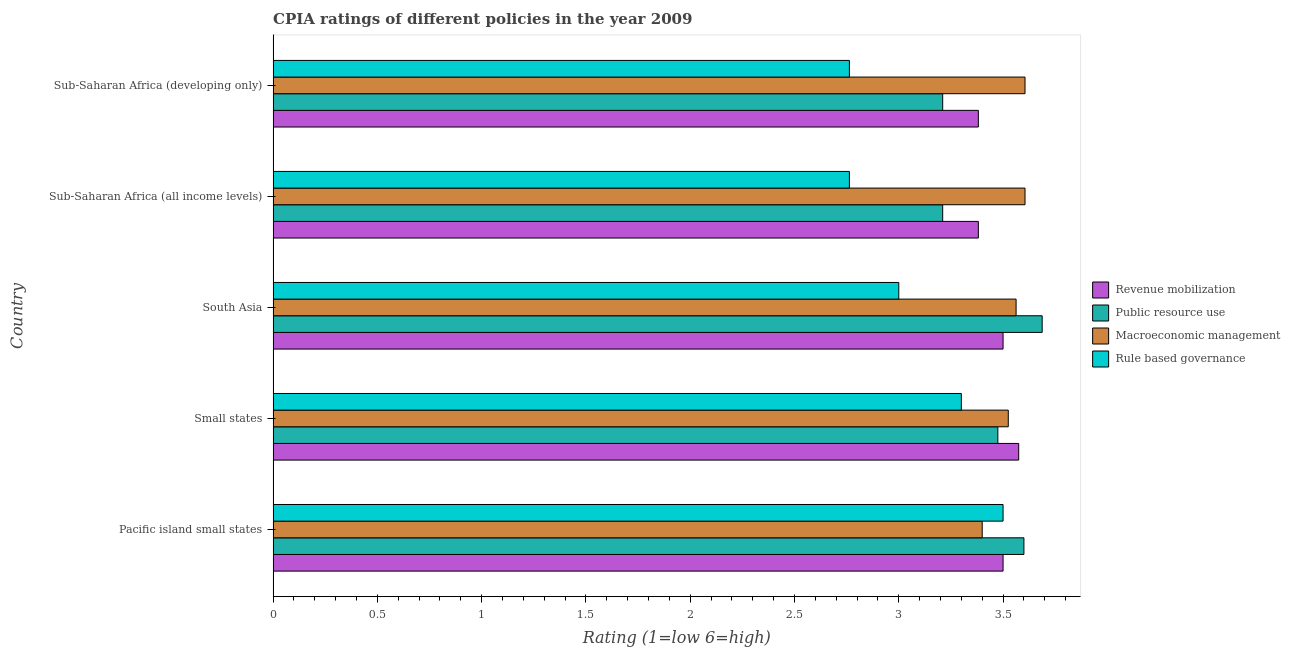How many groups of bars are there?
Offer a very short reply. 5. Are the number of bars per tick equal to the number of legend labels?
Make the answer very short. Yes. What is the label of the 1st group of bars from the top?
Offer a terse response. Sub-Saharan Africa (developing only). What is the cpia rating of public resource use in Sub-Saharan Africa (developing only)?
Offer a terse response. 3.21. Across all countries, what is the maximum cpia rating of public resource use?
Your answer should be compact. 3.69. Across all countries, what is the minimum cpia rating of rule based governance?
Give a very brief answer. 2.76. In which country was the cpia rating of rule based governance maximum?
Your answer should be compact. Pacific island small states. In which country was the cpia rating of revenue mobilization minimum?
Keep it short and to the point. Sub-Saharan Africa (all income levels). What is the total cpia rating of revenue mobilization in the graph?
Give a very brief answer. 17.34. What is the difference between the cpia rating of revenue mobilization in Small states and that in Sub-Saharan Africa (developing only)?
Ensure brevity in your answer.  0.19. What is the difference between the cpia rating of public resource use in South Asia and the cpia rating of rule based governance in Small states?
Your answer should be very brief. 0.39. What is the average cpia rating of public resource use per country?
Your response must be concise. 3.44. In how many countries, is the cpia rating of revenue mobilization greater than 1.9 ?
Provide a short and direct response. 5. What is the ratio of the cpia rating of public resource use in Small states to that in Sub-Saharan Africa (developing only)?
Your answer should be compact. 1.08. Is the cpia rating of macroeconomic management in South Asia less than that in Sub-Saharan Africa (developing only)?
Keep it short and to the point. Yes. What is the difference between the highest and the lowest cpia rating of revenue mobilization?
Your answer should be compact. 0.19. In how many countries, is the cpia rating of public resource use greater than the average cpia rating of public resource use taken over all countries?
Your answer should be very brief. 3. What does the 1st bar from the top in Pacific island small states represents?
Provide a succinct answer. Rule based governance. What does the 1st bar from the bottom in South Asia represents?
Give a very brief answer. Revenue mobilization. Are all the bars in the graph horizontal?
Give a very brief answer. Yes. Are the values on the major ticks of X-axis written in scientific E-notation?
Make the answer very short. No. Does the graph contain any zero values?
Make the answer very short. No. Does the graph contain grids?
Offer a terse response. No. Where does the legend appear in the graph?
Offer a terse response. Center right. How many legend labels are there?
Give a very brief answer. 4. What is the title of the graph?
Offer a terse response. CPIA ratings of different policies in the year 2009. Does "Plant species" appear as one of the legend labels in the graph?
Your answer should be compact. No. What is the label or title of the X-axis?
Offer a terse response. Rating (1=low 6=high). What is the label or title of the Y-axis?
Offer a terse response. Country. What is the Rating (1=low 6=high) of Public resource use in Pacific island small states?
Make the answer very short. 3.6. What is the Rating (1=low 6=high) of Macroeconomic management in Pacific island small states?
Provide a succinct answer. 3.4. What is the Rating (1=low 6=high) of Rule based governance in Pacific island small states?
Your response must be concise. 3.5. What is the Rating (1=low 6=high) in Revenue mobilization in Small states?
Offer a terse response. 3.58. What is the Rating (1=low 6=high) of Public resource use in Small states?
Provide a short and direct response. 3.48. What is the Rating (1=low 6=high) in Macroeconomic management in Small states?
Your answer should be very brief. 3.52. What is the Rating (1=low 6=high) in Revenue mobilization in South Asia?
Keep it short and to the point. 3.5. What is the Rating (1=low 6=high) in Public resource use in South Asia?
Your answer should be very brief. 3.69. What is the Rating (1=low 6=high) in Macroeconomic management in South Asia?
Your answer should be compact. 3.56. What is the Rating (1=low 6=high) of Rule based governance in South Asia?
Make the answer very short. 3. What is the Rating (1=low 6=high) in Revenue mobilization in Sub-Saharan Africa (all income levels)?
Provide a succinct answer. 3.38. What is the Rating (1=low 6=high) of Public resource use in Sub-Saharan Africa (all income levels)?
Make the answer very short. 3.21. What is the Rating (1=low 6=high) in Macroeconomic management in Sub-Saharan Africa (all income levels)?
Your response must be concise. 3.61. What is the Rating (1=low 6=high) in Rule based governance in Sub-Saharan Africa (all income levels)?
Provide a succinct answer. 2.76. What is the Rating (1=low 6=high) in Revenue mobilization in Sub-Saharan Africa (developing only)?
Your answer should be very brief. 3.38. What is the Rating (1=low 6=high) in Public resource use in Sub-Saharan Africa (developing only)?
Ensure brevity in your answer.  3.21. What is the Rating (1=low 6=high) of Macroeconomic management in Sub-Saharan Africa (developing only)?
Offer a terse response. 3.61. What is the Rating (1=low 6=high) of Rule based governance in Sub-Saharan Africa (developing only)?
Provide a succinct answer. 2.76. Across all countries, what is the maximum Rating (1=low 6=high) of Revenue mobilization?
Your response must be concise. 3.58. Across all countries, what is the maximum Rating (1=low 6=high) of Public resource use?
Your answer should be compact. 3.69. Across all countries, what is the maximum Rating (1=low 6=high) in Macroeconomic management?
Ensure brevity in your answer.  3.61. Across all countries, what is the minimum Rating (1=low 6=high) in Revenue mobilization?
Your response must be concise. 3.38. Across all countries, what is the minimum Rating (1=low 6=high) in Public resource use?
Provide a succinct answer. 3.21. Across all countries, what is the minimum Rating (1=low 6=high) of Rule based governance?
Offer a very short reply. 2.76. What is the total Rating (1=low 6=high) of Revenue mobilization in the graph?
Give a very brief answer. 17.34. What is the total Rating (1=low 6=high) of Public resource use in the graph?
Your answer should be compact. 17.18. What is the total Rating (1=low 6=high) of Macroeconomic management in the graph?
Make the answer very short. 17.7. What is the total Rating (1=low 6=high) of Rule based governance in the graph?
Make the answer very short. 15.33. What is the difference between the Rating (1=low 6=high) of Revenue mobilization in Pacific island small states and that in Small states?
Your answer should be very brief. -0.07. What is the difference between the Rating (1=low 6=high) of Public resource use in Pacific island small states and that in Small states?
Your answer should be very brief. 0.12. What is the difference between the Rating (1=low 6=high) of Macroeconomic management in Pacific island small states and that in Small states?
Your answer should be compact. -0.12. What is the difference between the Rating (1=low 6=high) of Rule based governance in Pacific island small states and that in Small states?
Ensure brevity in your answer.  0.2. What is the difference between the Rating (1=low 6=high) in Public resource use in Pacific island small states and that in South Asia?
Offer a very short reply. -0.09. What is the difference between the Rating (1=low 6=high) of Macroeconomic management in Pacific island small states and that in South Asia?
Make the answer very short. -0.16. What is the difference between the Rating (1=low 6=high) in Rule based governance in Pacific island small states and that in South Asia?
Provide a succinct answer. 0.5. What is the difference between the Rating (1=low 6=high) in Revenue mobilization in Pacific island small states and that in Sub-Saharan Africa (all income levels)?
Make the answer very short. 0.12. What is the difference between the Rating (1=low 6=high) in Public resource use in Pacific island small states and that in Sub-Saharan Africa (all income levels)?
Your response must be concise. 0.39. What is the difference between the Rating (1=low 6=high) in Macroeconomic management in Pacific island small states and that in Sub-Saharan Africa (all income levels)?
Offer a very short reply. -0.21. What is the difference between the Rating (1=low 6=high) in Rule based governance in Pacific island small states and that in Sub-Saharan Africa (all income levels)?
Give a very brief answer. 0.74. What is the difference between the Rating (1=low 6=high) of Revenue mobilization in Pacific island small states and that in Sub-Saharan Africa (developing only)?
Your response must be concise. 0.12. What is the difference between the Rating (1=low 6=high) of Public resource use in Pacific island small states and that in Sub-Saharan Africa (developing only)?
Make the answer very short. 0.39. What is the difference between the Rating (1=low 6=high) in Macroeconomic management in Pacific island small states and that in Sub-Saharan Africa (developing only)?
Keep it short and to the point. -0.21. What is the difference between the Rating (1=low 6=high) of Rule based governance in Pacific island small states and that in Sub-Saharan Africa (developing only)?
Make the answer very short. 0.74. What is the difference between the Rating (1=low 6=high) of Revenue mobilization in Small states and that in South Asia?
Offer a very short reply. 0.07. What is the difference between the Rating (1=low 6=high) in Public resource use in Small states and that in South Asia?
Provide a succinct answer. -0.21. What is the difference between the Rating (1=low 6=high) in Macroeconomic management in Small states and that in South Asia?
Ensure brevity in your answer.  -0.04. What is the difference between the Rating (1=low 6=high) of Revenue mobilization in Small states and that in Sub-Saharan Africa (all income levels)?
Your answer should be very brief. 0.19. What is the difference between the Rating (1=low 6=high) of Public resource use in Small states and that in Sub-Saharan Africa (all income levels)?
Your answer should be very brief. 0.26. What is the difference between the Rating (1=low 6=high) of Macroeconomic management in Small states and that in Sub-Saharan Africa (all income levels)?
Ensure brevity in your answer.  -0.08. What is the difference between the Rating (1=low 6=high) of Rule based governance in Small states and that in Sub-Saharan Africa (all income levels)?
Keep it short and to the point. 0.54. What is the difference between the Rating (1=low 6=high) of Revenue mobilization in Small states and that in Sub-Saharan Africa (developing only)?
Offer a terse response. 0.19. What is the difference between the Rating (1=low 6=high) of Public resource use in Small states and that in Sub-Saharan Africa (developing only)?
Your response must be concise. 0.26. What is the difference between the Rating (1=low 6=high) in Macroeconomic management in Small states and that in Sub-Saharan Africa (developing only)?
Provide a short and direct response. -0.08. What is the difference between the Rating (1=low 6=high) of Rule based governance in Small states and that in Sub-Saharan Africa (developing only)?
Offer a very short reply. 0.54. What is the difference between the Rating (1=low 6=high) of Revenue mobilization in South Asia and that in Sub-Saharan Africa (all income levels)?
Your answer should be compact. 0.12. What is the difference between the Rating (1=low 6=high) of Public resource use in South Asia and that in Sub-Saharan Africa (all income levels)?
Your answer should be compact. 0.48. What is the difference between the Rating (1=low 6=high) of Macroeconomic management in South Asia and that in Sub-Saharan Africa (all income levels)?
Ensure brevity in your answer.  -0.04. What is the difference between the Rating (1=low 6=high) of Rule based governance in South Asia and that in Sub-Saharan Africa (all income levels)?
Provide a short and direct response. 0.24. What is the difference between the Rating (1=low 6=high) in Revenue mobilization in South Asia and that in Sub-Saharan Africa (developing only)?
Ensure brevity in your answer.  0.12. What is the difference between the Rating (1=low 6=high) of Public resource use in South Asia and that in Sub-Saharan Africa (developing only)?
Your response must be concise. 0.48. What is the difference between the Rating (1=low 6=high) of Macroeconomic management in South Asia and that in Sub-Saharan Africa (developing only)?
Your response must be concise. -0.04. What is the difference between the Rating (1=low 6=high) of Rule based governance in South Asia and that in Sub-Saharan Africa (developing only)?
Keep it short and to the point. 0.24. What is the difference between the Rating (1=low 6=high) in Revenue mobilization in Pacific island small states and the Rating (1=low 6=high) in Public resource use in Small states?
Provide a short and direct response. 0.03. What is the difference between the Rating (1=low 6=high) in Revenue mobilization in Pacific island small states and the Rating (1=low 6=high) in Macroeconomic management in Small states?
Keep it short and to the point. -0.03. What is the difference between the Rating (1=low 6=high) in Revenue mobilization in Pacific island small states and the Rating (1=low 6=high) in Rule based governance in Small states?
Provide a succinct answer. 0.2. What is the difference between the Rating (1=low 6=high) of Public resource use in Pacific island small states and the Rating (1=low 6=high) of Macroeconomic management in Small states?
Provide a succinct answer. 0.07. What is the difference between the Rating (1=low 6=high) in Macroeconomic management in Pacific island small states and the Rating (1=low 6=high) in Rule based governance in Small states?
Provide a short and direct response. 0.1. What is the difference between the Rating (1=low 6=high) of Revenue mobilization in Pacific island small states and the Rating (1=low 6=high) of Public resource use in South Asia?
Make the answer very short. -0.19. What is the difference between the Rating (1=low 6=high) in Revenue mobilization in Pacific island small states and the Rating (1=low 6=high) in Macroeconomic management in South Asia?
Your response must be concise. -0.06. What is the difference between the Rating (1=low 6=high) of Revenue mobilization in Pacific island small states and the Rating (1=low 6=high) of Rule based governance in South Asia?
Make the answer very short. 0.5. What is the difference between the Rating (1=low 6=high) of Public resource use in Pacific island small states and the Rating (1=low 6=high) of Macroeconomic management in South Asia?
Provide a short and direct response. 0.04. What is the difference between the Rating (1=low 6=high) of Revenue mobilization in Pacific island small states and the Rating (1=low 6=high) of Public resource use in Sub-Saharan Africa (all income levels)?
Your response must be concise. 0.29. What is the difference between the Rating (1=low 6=high) of Revenue mobilization in Pacific island small states and the Rating (1=low 6=high) of Macroeconomic management in Sub-Saharan Africa (all income levels)?
Provide a short and direct response. -0.11. What is the difference between the Rating (1=low 6=high) of Revenue mobilization in Pacific island small states and the Rating (1=low 6=high) of Rule based governance in Sub-Saharan Africa (all income levels)?
Ensure brevity in your answer.  0.74. What is the difference between the Rating (1=low 6=high) of Public resource use in Pacific island small states and the Rating (1=low 6=high) of Macroeconomic management in Sub-Saharan Africa (all income levels)?
Your response must be concise. -0.01. What is the difference between the Rating (1=low 6=high) in Public resource use in Pacific island small states and the Rating (1=low 6=high) in Rule based governance in Sub-Saharan Africa (all income levels)?
Ensure brevity in your answer.  0.84. What is the difference between the Rating (1=low 6=high) of Macroeconomic management in Pacific island small states and the Rating (1=low 6=high) of Rule based governance in Sub-Saharan Africa (all income levels)?
Offer a terse response. 0.64. What is the difference between the Rating (1=low 6=high) in Revenue mobilization in Pacific island small states and the Rating (1=low 6=high) in Public resource use in Sub-Saharan Africa (developing only)?
Keep it short and to the point. 0.29. What is the difference between the Rating (1=low 6=high) of Revenue mobilization in Pacific island small states and the Rating (1=low 6=high) of Macroeconomic management in Sub-Saharan Africa (developing only)?
Your answer should be compact. -0.11. What is the difference between the Rating (1=low 6=high) in Revenue mobilization in Pacific island small states and the Rating (1=low 6=high) in Rule based governance in Sub-Saharan Africa (developing only)?
Provide a short and direct response. 0.74. What is the difference between the Rating (1=low 6=high) in Public resource use in Pacific island small states and the Rating (1=low 6=high) in Macroeconomic management in Sub-Saharan Africa (developing only)?
Provide a short and direct response. -0.01. What is the difference between the Rating (1=low 6=high) of Public resource use in Pacific island small states and the Rating (1=low 6=high) of Rule based governance in Sub-Saharan Africa (developing only)?
Your answer should be compact. 0.84. What is the difference between the Rating (1=low 6=high) of Macroeconomic management in Pacific island small states and the Rating (1=low 6=high) of Rule based governance in Sub-Saharan Africa (developing only)?
Provide a short and direct response. 0.64. What is the difference between the Rating (1=low 6=high) of Revenue mobilization in Small states and the Rating (1=low 6=high) of Public resource use in South Asia?
Keep it short and to the point. -0.11. What is the difference between the Rating (1=low 6=high) of Revenue mobilization in Small states and the Rating (1=low 6=high) of Macroeconomic management in South Asia?
Your answer should be compact. 0.01. What is the difference between the Rating (1=low 6=high) of Revenue mobilization in Small states and the Rating (1=low 6=high) of Rule based governance in South Asia?
Ensure brevity in your answer.  0.57. What is the difference between the Rating (1=low 6=high) in Public resource use in Small states and the Rating (1=low 6=high) in Macroeconomic management in South Asia?
Ensure brevity in your answer.  -0.09. What is the difference between the Rating (1=low 6=high) of Public resource use in Small states and the Rating (1=low 6=high) of Rule based governance in South Asia?
Your response must be concise. 0.47. What is the difference between the Rating (1=low 6=high) of Macroeconomic management in Small states and the Rating (1=low 6=high) of Rule based governance in South Asia?
Your answer should be very brief. 0.53. What is the difference between the Rating (1=low 6=high) of Revenue mobilization in Small states and the Rating (1=low 6=high) of Public resource use in Sub-Saharan Africa (all income levels)?
Give a very brief answer. 0.36. What is the difference between the Rating (1=low 6=high) in Revenue mobilization in Small states and the Rating (1=low 6=high) in Macroeconomic management in Sub-Saharan Africa (all income levels)?
Your answer should be very brief. -0.03. What is the difference between the Rating (1=low 6=high) of Revenue mobilization in Small states and the Rating (1=low 6=high) of Rule based governance in Sub-Saharan Africa (all income levels)?
Give a very brief answer. 0.81. What is the difference between the Rating (1=low 6=high) of Public resource use in Small states and the Rating (1=low 6=high) of Macroeconomic management in Sub-Saharan Africa (all income levels)?
Make the answer very short. -0.13. What is the difference between the Rating (1=low 6=high) in Public resource use in Small states and the Rating (1=low 6=high) in Rule based governance in Sub-Saharan Africa (all income levels)?
Keep it short and to the point. 0.71. What is the difference between the Rating (1=low 6=high) in Macroeconomic management in Small states and the Rating (1=low 6=high) in Rule based governance in Sub-Saharan Africa (all income levels)?
Provide a succinct answer. 0.76. What is the difference between the Rating (1=low 6=high) of Revenue mobilization in Small states and the Rating (1=low 6=high) of Public resource use in Sub-Saharan Africa (developing only)?
Your answer should be very brief. 0.36. What is the difference between the Rating (1=low 6=high) of Revenue mobilization in Small states and the Rating (1=low 6=high) of Macroeconomic management in Sub-Saharan Africa (developing only)?
Offer a terse response. -0.03. What is the difference between the Rating (1=low 6=high) in Revenue mobilization in Small states and the Rating (1=low 6=high) in Rule based governance in Sub-Saharan Africa (developing only)?
Offer a very short reply. 0.81. What is the difference between the Rating (1=low 6=high) in Public resource use in Small states and the Rating (1=low 6=high) in Macroeconomic management in Sub-Saharan Africa (developing only)?
Provide a succinct answer. -0.13. What is the difference between the Rating (1=low 6=high) of Public resource use in Small states and the Rating (1=low 6=high) of Rule based governance in Sub-Saharan Africa (developing only)?
Offer a terse response. 0.71. What is the difference between the Rating (1=low 6=high) of Macroeconomic management in Small states and the Rating (1=low 6=high) of Rule based governance in Sub-Saharan Africa (developing only)?
Offer a very short reply. 0.76. What is the difference between the Rating (1=low 6=high) in Revenue mobilization in South Asia and the Rating (1=low 6=high) in Public resource use in Sub-Saharan Africa (all income levels)?
Provide a short and direct response. 0.29. What is the difference between the Rating (1=low 6=high) in Revenue mobilization in South Asia and the Rating (1=low 6=high) in Macroeconomic management in Sub-Saharan Africa (all income levels)?
Offer a very short reply. -0.11. What is the difference between the Rating (1=low 6=high) in Revenue mobilization in South Asia and the Rating (1=low 6=high) in Rule based governance in Sub-Saharan Africa (all income levels)?
Give a very brief answer. 0.74. What is the difference between the Rating (1=low 6=high) in Public resource use in South Asia and the Rating (1=low 6=high) in Macroeconomic management in Sub-Saharan Africa (all income levels)?
Your answer should be very brief. 0.08. What is the difference between the Rating (1=low 6=high) in Public resource use in South Asia and the Rating (1=low 6=high) in Rule based governance in Sub-Saharan Africa (all income levels)?
Offer a very short reply. 0.92. What is the difference between the Rating (1=low 6=high) in Macroeconomic management in South Asia and the Rating (1=low 6=high) in Rule based governance in Sub-Saharan Africa (all income levels)?
Offer a terse response. 0.8. What is the difference between the Rating (1=low 6=high) in Revenue mobilization in South Asia and the Rating (1=low 6=high) in Public resource use in Sub-Saharan Africa (developing only)?
Ensure brevity in your answer.  0.29. What is the difference between the Rating (1=low 6=high) in Revenue mobilization in South Asia and the Rating (1=low 6=high) in Macroeconomic management in Sub-Saharan Africa (developing only)?
Give a very brief answer. -0.11. What is the difference between the Rating (1=low 6=high) of Revenue mobilization in South Asia and the Rating (1=low 6=high) of Rule based governance in Sub-Saharan Africa (developing only)?
Provide a succinct answer. 0.74. What is the difference between the Rating (1=low 6=high) of Public resource use in South Asia and the Rating (1=low 6=high) of Macroeconomic management in Sub-Saharan Africa (developing only)?
Provide a short and direct response. 0.08. What is the difference between the Rating (1=low 6=high) in Public resource use in South Asia and the Rating (1=low 6=high) in Rule based governance in Sub-Saharan Africa (developing only)?
Provide a succinct answer. 0.92. What is the difference between the Rating (1=low 6=high) of Macroeconomic management in South Asia and the Rating (1=low 6=high) of Rule based governance in Sub-Saharan Africa (developing only)?
Your response must be concise. 0.8. What is the difference between the Rating (1=low 6=high) in Revenue mobilization in Sub-Saharan Africa (all income levels) and the Rating (1=low 6=high) in Public resource use in Sub-Saharan Africa (developing only)?
Provide a succinct answer. 0.17. What is the difference between the Rating (1=low 6=high) of Revenue mobilization in Sub-Saharan Africa (all income levels) and the Rating (1=low 6=high) of Macroeconomic management in Sub-Saharan Africa (developing only)?
Offer a very short reply. -0.22. What is the difference between the Rating (1=low 6=high) in Revenue mobilization in Sub-Saharan Africa (all income levels) and the Rating (1=low 6=high) in Rule based governance in Sub-Saharan Africa (developing only)?
Your answer should be very brief. 0.62. What is the difference between the Rating (1=low 6=high) of Public resource use in Sub-Saharan Africa (all income levels) and the Rating (1=low 6=high) of Macroeconomic management in Sub-Saharan Africa (developing only)?
Give a very brief answer. -0.39. What is the difference between the Rating (1=low 6=high) of Public resource use in Sub-Saharan Africa (all income levels) and the Rating (1=low 6=high) of Rule based governance in Sub-Saharan Africa (developing only)?
Your answer should be compact. 0.45. What is the difference between the Rating (1=low 6=high) of Macroeconomic management in Sub-Saharan Africa (all income levels) and the Rating (1=low 6=high) of Rule based governance in Sub-Saharan Africa (developing only)?
Offer a very short reply. 0.84. What is the average Rating (1=low 6=high) in Revenue mobilization per country?
Provide a succinct answer. 3.47. What is the average Rating (1=low 6=high) of Public resource use per country?
Your answer should be compact. 3.44. What is the average Rating (1=low 6=high) in Macroeconomic management per country?
Your answer should be compact. 3.54. What is the average Rating (1=low 6=high) of Rule based governance per country?
Offer a terse response. 3.07. What is the difference between the Rating (1=low 6=high) of Revenue mobilization and Rating (1=low 6=high) of Macroeconomic management in Pacific island small states?
Make the answer very short. 0.1. What is the difference between the Rating (1=low 6=high) in Macroeconomic management and Rating (1=low 6=high) in Rule based governance in Pacific island small states?
Offer a very short reply. -0.1. What is the difference between the Rating (1=low 6=high) of Revenue mobilization and Rating (1=low 6=high) of Macroeconomic management in Small states?
Offer a very short reply. 0.05. What is the difference between the Rating (1=low 6=high) of Revenue mobilization and Rating (1=low 6=high) of Rule based governance in Small states?
Your response must be concise. 0.28. What is the difference between the Rating (1=low 6=high) in Public resource use and Rating (1=low 6=high) in Macroeconomic management in Small states?
Ensure brevity in your answer.  -0.05. What is the difference between the Rating (1=low 6=high) in Public resource use and Rating (1=low 6=high) in Rule based governance in Small states?
Ensure brevity in your answer.  0.17. What is the difference between the Rating (1=low 6=high) of Macroeconomic management and Rating (1=low 6=high) of Rule based governance in Small states?
Your answer should be very brief. 0.23. What is the difference between the Rating (1=low 6=high) in Revenue mobilization and Rating (1=low 6=high) in Public resource use in South Asia?
Provide a short and direct response. -0.19. What is the difference between the Rating (1=low 6=high) in Revenue mobilization and Rating (1=low 6=high) in Macroeconomic management in South Asia?
Your answer should be very brief. -0.06. What is the difference between the Rating (1=low 6=high) of Public resource use and Rating (1=low 6=high) of Macroeconomic management in South Asia?
Keep it short and to the point. 0.12. What is the difference between the Rating (1=low 6=high) in Public resource use and Rating (1=low 6=high) in Rule based governance in South Asia?
Provide a succinct answer. 0.69. What is the difference between the Rating (1=low 6=high) of Macroeconomic management and Rating (1=low 6=high) of Rule based governance in South Asia?
Give a very brief answer. 0.56. What is the difference between the Rating (1=low 6=high) in Revenue mobilization and Rating (1=low 6=high) in Public resource use in Sub-Saharan Africa (all income levels)?
Keep it short and to the point. 0.17. What is the difference between the Rating (1=low 6=high) of Revenue mobilization and Rating (1=low 6=high) of Macroeconomic management in Sub-Saharan Africa (all income levels)?
Your answer should be compact. -0.22. What is the difference between the Rating (1=low 6=high) of Revenue mobilization and Rating (1=low 6=high) of Rule based governance in Sub-Saharan Africa (all income levels)?
Your answer should be very brief. 0.62. What is the difference between the Rating (1=low 6=high) of Public resource use and Rating (1=low 6=high) of Macroeconomic management in Sub-Saharan Africa (all income levels)?
Provide a short and direct response. -0.39. What is the difference between the Rating (1=low 6=high) of Public resource use and Rating (1=low 6=high) of Rule based governance in Sub-Saharan Africa (all income levels)?
Your answer should be compact. 0.45. What is the difference between the Rating (1=low 6=high) of Macroeconomic management and Rating (1=low 6=high) of Rule based governance in Sub-Saharan Africa (all income levels)?
Offer a terse response. 0.84. What is the difference between the Rating (1=low 6=high) of Revenue mobilization and Rating (1=low 6=high) of Public resource use in Sub-Saharan Africa (developing only)?
Provide a succinct answer. 0.17. What is the difference between the Rating (1=low 6=high) in Revenue mobilization and Rating (1=low 6=high) in Macroeconomic management in Sub-Saharan Africa (developing only)?
Offer a terse response. -0.22. What is the difference between the Rating (1=low 6=high) of Revenue mobilization and Rating (1=low 6=high) of Rule based governance in Sub-Saharan Africa (developing only)?
Provide a succinct answer. 0.62. What is the difference between the Rating (1=low 6=high) of Public resource use and Rating (1=low 6=high) of Macroeconomic management in Sub-Saharan Africa (developing only)?
Provide a succinct answer. -0.39. What is the difference between the Rating (1=low 6=high) of Public resource use and Rating (1=low 6=high) of Rule based governance in Sub-Saharan Africa (developing only)?
Your answer should be very brief. 0.45. What is the difference between the Rating (1=low 6=high) in Macroeconomic management and Rating (1=low 6=high) in Rule based governance in Sub-Saharan Africa (developing only)?
Give a very brief answer. 0.84. What is the ratio of the Rating (1=low 6=high) of Public resource use in Pacific island small states to that in Small states?
Your response must be concise. 1.04. What is the ratio of the Rating (1=low 6=high) of Macroeconomic management in Pacific island small states to that in Small states?
Your answer should be compact. 0.96. What is the ratio of the Rating (1=low 6=high) of Rule based governance in Pacific island small states to that in Small states?
Give a very brief answer. 1.06. What is the ratio of the Rating (1=low 6=high) in Revenue mobilization in Pacific island small states to that in South Asia?
Ensure brevity in your answer.  1. What is the ratio of the Rating (1=low 6=high) in Public resource use in Pacific island small states to that in South Asia?
Provide a short and direct response. 0.98. What is the ratio of the Rating (1=low 6=high) in Macroeconomic management in Pacific island small states to that in South Asia?
Give a very brief answer. 0.95. What is the ratio of the Rating (1=low 6=high) of Rule based governance in Pacific island small states to that in South Asia?
Ensure brevity in your answer.  1.17. What is the ratio of the Rating (1=low 6=high) in Revenue mobilization in Pacific island small states to that in Sub-Saharan Africa (all income levels)?
Give a very brief answer. 1.03. What is the ratio of the Rating (1=low 6=high) of Public resource use in Pacific island small states to that in Sub-Saharan Africa (all income levels)?
Your answer should be compact. 1.12. What is the ratio of the Rating (1=low 6=high) of Macroeconomic management in Pacific island small states to that in Sub-Saharan Africa (all income levels)?
Provide a succinct answer. 0.94. What is the ratio of the Rating (1=low 6=high) of Rule based governance in Pacific island small states to that in Sub-Saharan Africa (all income levels)?
Your response must be concise. 1.27. What is the ratio of the Rating (1=low 6=high) in Revenue mobilization in Pacific island small states to that in Sub-Saharan Africa (developing only)?
Make the answer very short. 1.03. What is the ratio of the Rating (1=low 6=high) in Public resource use in Pacific island small states to that in Sub-Saharan Africa (developing only)?
Your response must be concise. 1.12. What is the ratio of the Rating (1=low 6=high) of Macroeconomic management in Pacific island small states to that in Sub-Saharan Africa (developing only)?
Keep it short and to the point. 0.94. What is the ratio of the Rating (1=low 6=high) of Rule based governance in Pacific island small states to that in Sub-Saharan Africa (developing only)?
Provide a succinct answer. 1.27. What is the ratio of the Rating (1=low 6=high) of Revenue mobilization in Small states to that in South Asia?
Your response must be concise. 1.02. What is the ratio of the Rating (1=low 6=high) of Public resource use in Small states to that in South Asia?
Keep it short and to the point. 0.94. What is the ratio of the Rating (1=low 6=high) of Revenue mobilization in Small states to that in Sub-Saharan Africa (all income levels)?
Offer a terse response. 1.06. What is the ratio of the Rating (1=low 6=high) in Public resource use in Small states to that in Sub-Saharan Africa (all income levels)?
Make the answer very short. 1.08. What is the ratio of the Rating (1=low 6=high) of Macroeconomic management in Small states to that in Sub-Saharan Africa (all income levels)?
Keep it short and to the point. 0.98. What is the ratio of the Rating (1=low 6=high) of Rule based governance in Small states to that in Sub-Saharan Africa (all income levels)?
Make the answer very short. 1.19. What is the ratio of the Rating (1=low 6=high) in Revenue mobilization in Small states to that in Sub-Saharan Africa (developing only)?
Offer a terse response. 1.06. What is the ratio of the Rating (1=low 6=high) of Public resource use in Small states to that in Sub-Saharan Africa (developing only)?
Give a very brief answer. 1.08. What is the ratio of the Rating (1=low 6=high) in Macroeconomic management in Small states to that in Sub-Saharan Africa (developing only)?
Your response must be concise. 0.98. What is the ratio of the Rating (1=low 6=high) in Rule based governance in Small states to that in Sub-Saharan Africa (developing only)?
Give a very brief answer. 1.19. What is the ratio of the Rating (1=low 6=high) in Revenue mobilization in South Asia to that in Sub-Saharan Africa (all income levels)?
Make the answer very short. 1.03. What is the ratio of the Rating (1=low 6=high) in Public resource use in South Asia to that in Sub-Saharan Africa (all income levels)?
Make the answer very short. 1.15. What is the ratio of the Rating (1=low 6=high) in Macroeconomic management in South Asia to that in Sub-Saharan Africa (all income levels)?
Make the answer very short. 0.99. What is the ratio of the Rating (1=low 6=high) in Rule based governance in South Asia to that in Sub-Saharan Africa (all income levels)?
Provide a succinct answer. 1.09. What is the ratio of the Rating (1=low 6=high) of Revenue mobilization in South Asia to that in Sub-Saharan Africa (developing only)?
Your answer should be very brief. 1.03. What is the ratio of the Rating (1=low 6=high) of Public resource use in South Asia to that in Sub-Saharan Africa (developing only)?
Make the answer very short. 1.15. What is the ratio of the Rating (1=low 6=high) of Rule based governance in South Asia to that in Sub-Saharan Africa (developing only)?
Your response must be concise. 1.09. What is the ratio of the Rating (1=low 6=high) of Revenue mobilization in Sub-Saharan Africa (all income levels) to that in Sub-Saharan Africa (developing only)?
Ensure brevity in your answer.  1. What is the difference between the highest and the second highest Rating (1=low 6=high) of Revenue mobilization?
Your answer should be very brief. 0.07. What is the difference between the highest and the second highest Rating (1=low 6=high) of Public resource use?
Offer a very short reply. 0.09. What is the difference between the highest and the second highest Rating (1=low 6=high) of Rule based governance?
Provide a short and direct response. 0.2. What is the difference between the highest and the lowest Rating (1=low 6=high) in Revenue mobilization?
Offer a terse response. 0.19. What is the difference between the highest and the lowest Rating (1=low 6=high) of Public resource use?
Make the answer very short. 0.48. What is the difference between the highest and the lowest Rating (1=low 6=high) in Macroeconomic management?
Provide a succinct answer. 0.21. What is the difference between the highest and the lowest Rating (1=low 6=high) of Rule based governance?
Provide a short and direct response. 0.74. 